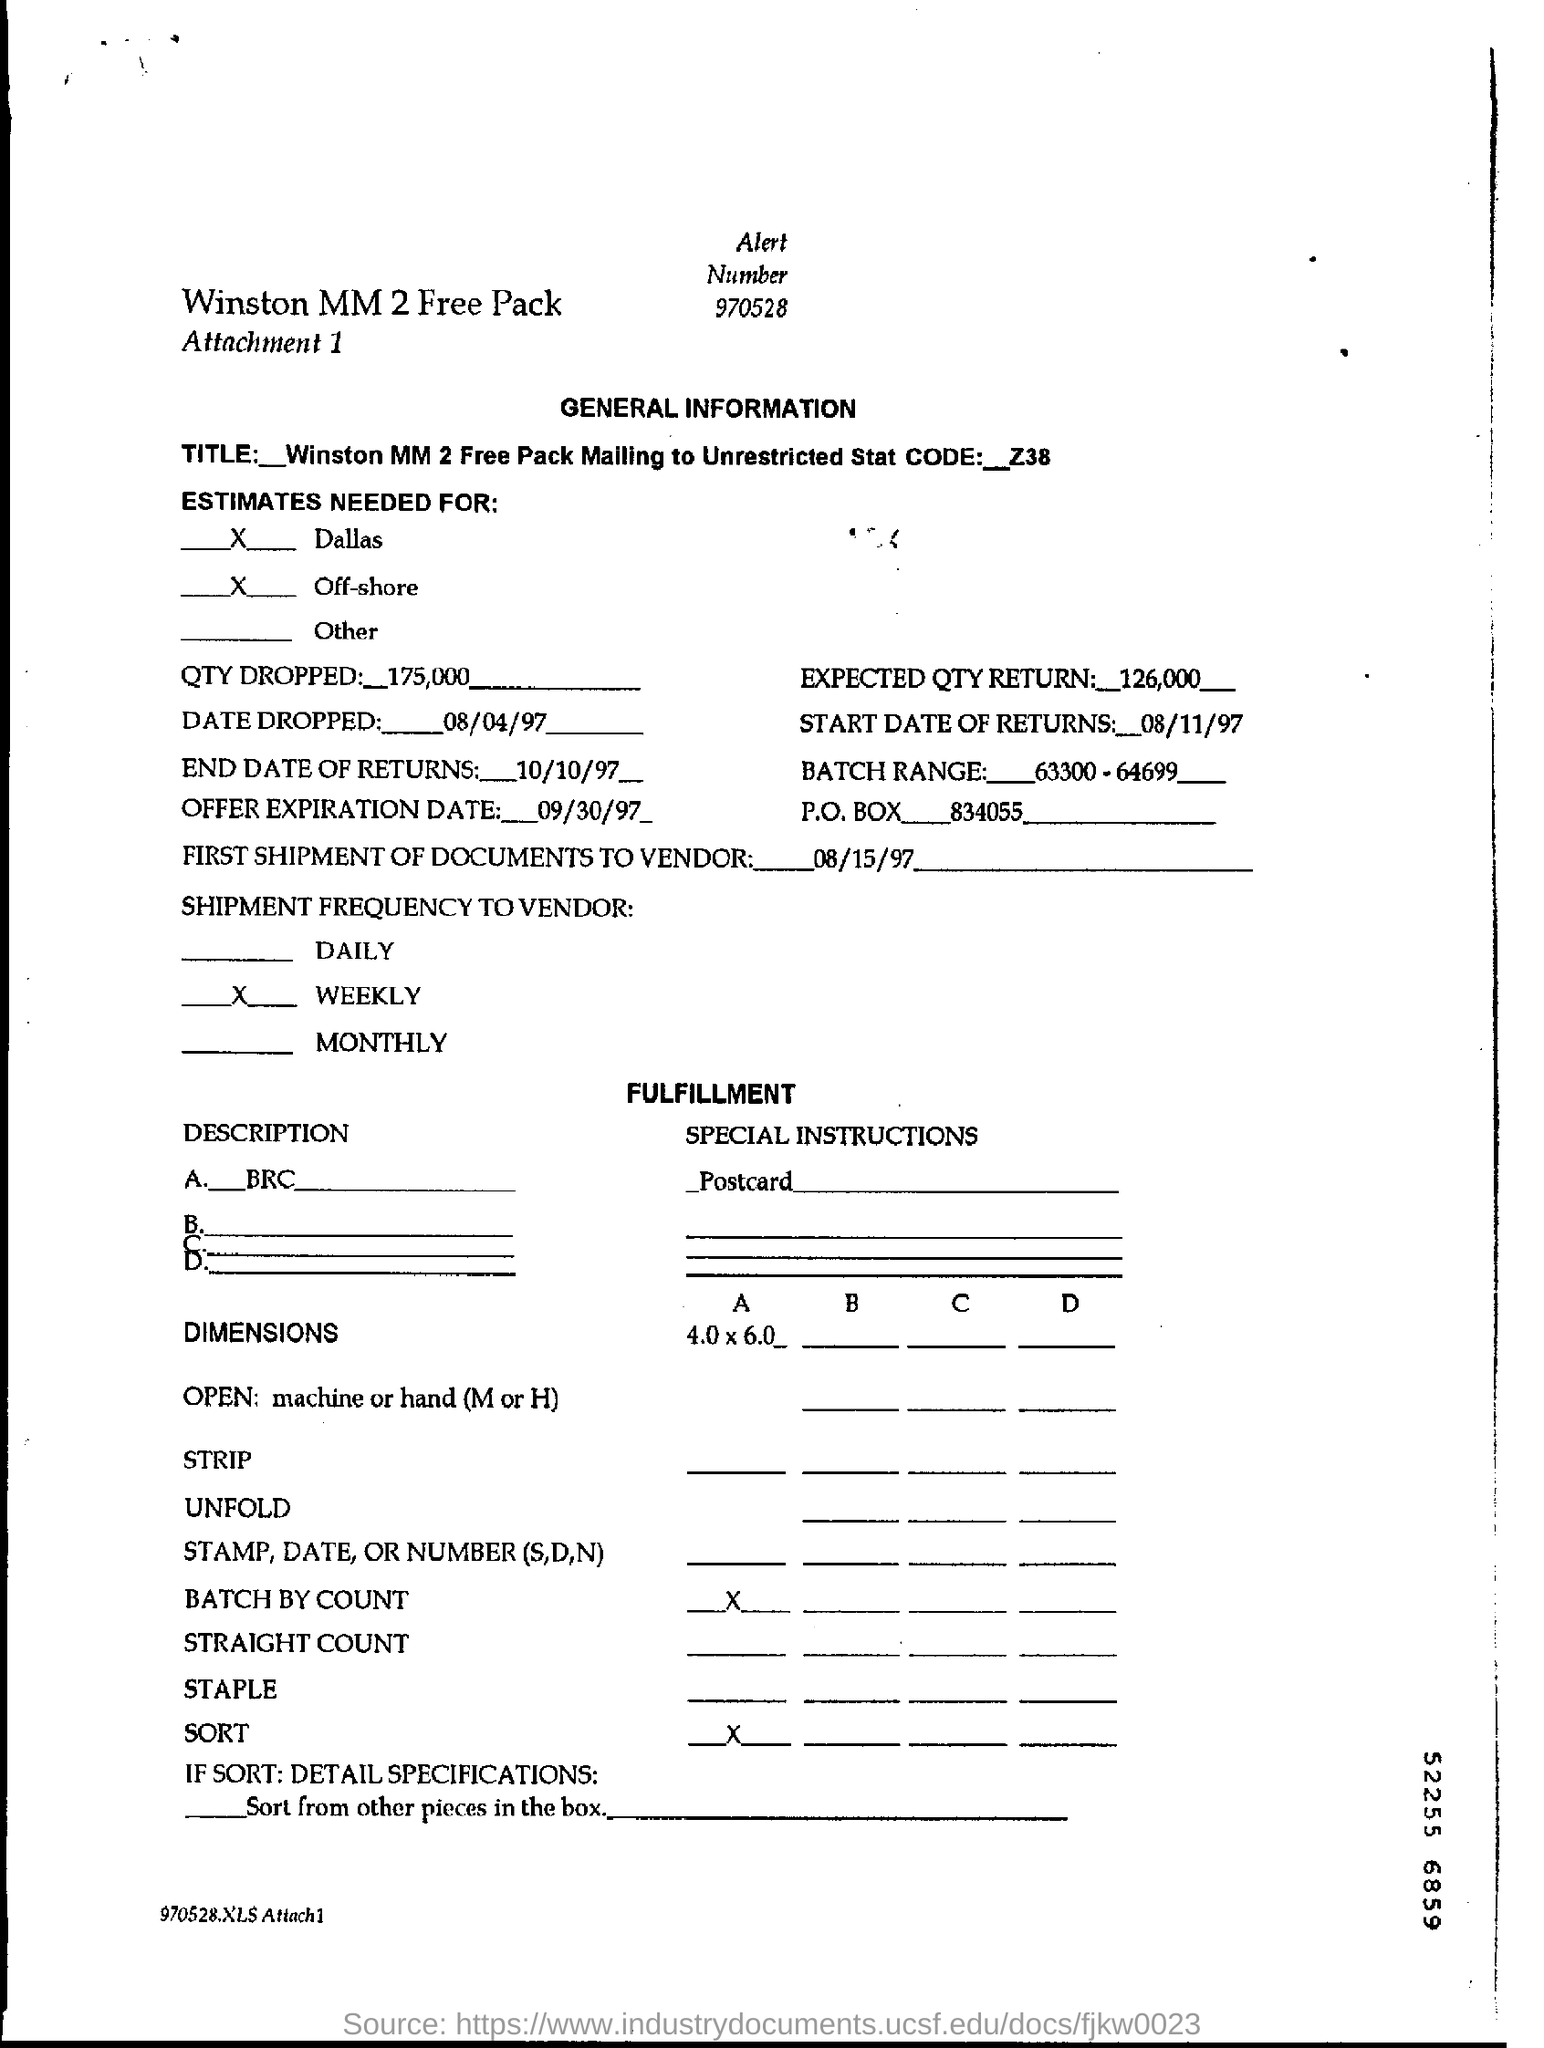What is the Alert Number ?
Offer a very short reply. 970528. What is the Attachment Number ?
Make the answer very short. Attachment 1. What type of information showing this document ?
Give a very brief answer. General information. What is the P.O Box Number ?
Your response must be concise. 834055. What is the Batch Range ?
Give a very brief answer. 63300-64699. What is the Offer Expiration Date ?
Keep it short and to the point. 09/30/97. What is written in the QTY Dropped Field ?
Keep it short and to the point. 175,000. What is the End Date of Returns ?
Your response must be concise. 10/10/97. What is the date of first shipment of documents to vendor ?
Your answer should be compact. 08/15/97. What is written in the Expected QTY Return Field ?
Give a very brief answer. 126,000. 